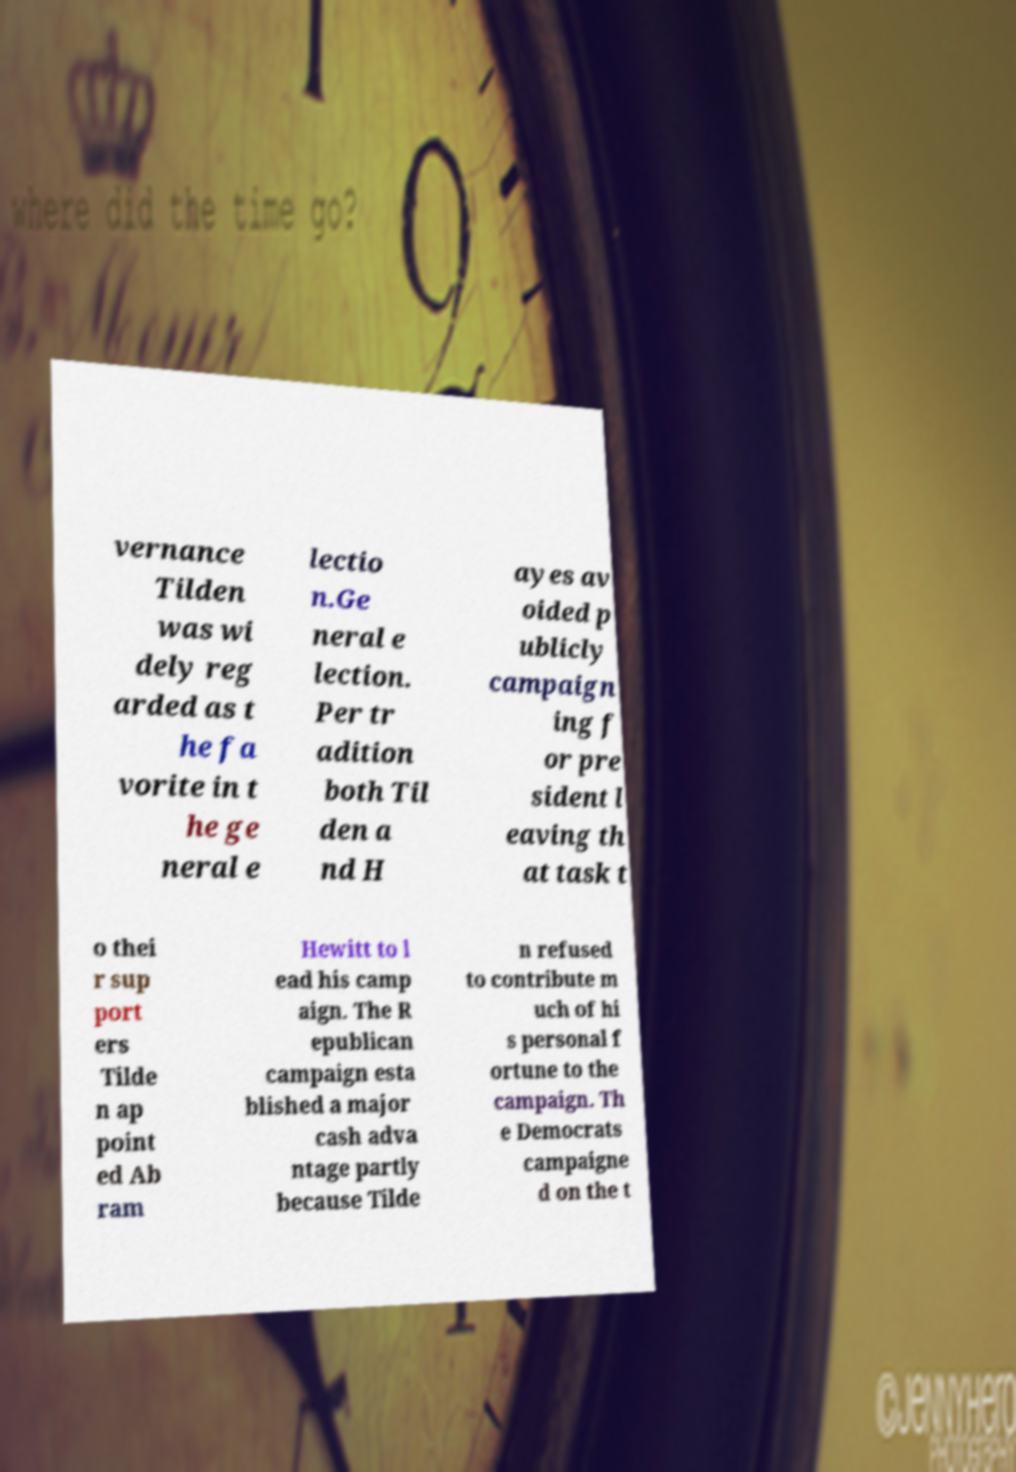Could you assist in decoding the text presented in this image and type it out clearly? vernance Tilden was wi dely reg arded as t he fa vorite in t he ge neral e lectio n.Ge neral e lection. Per tr adition both Til den a nd H ayes av oided p ublicly campaign ing f or pre sident l eaving th at task t o thei r sup port ers Tilde n ap point ed Ab ram Hewitt to l ead his camp aign. The R epublican campaign esta blished a major cash adva ntage partly because Tilde n refused to contribute m uch of hi s personal f ortune to the campaign. Th e Democrats campaigne d on the t 